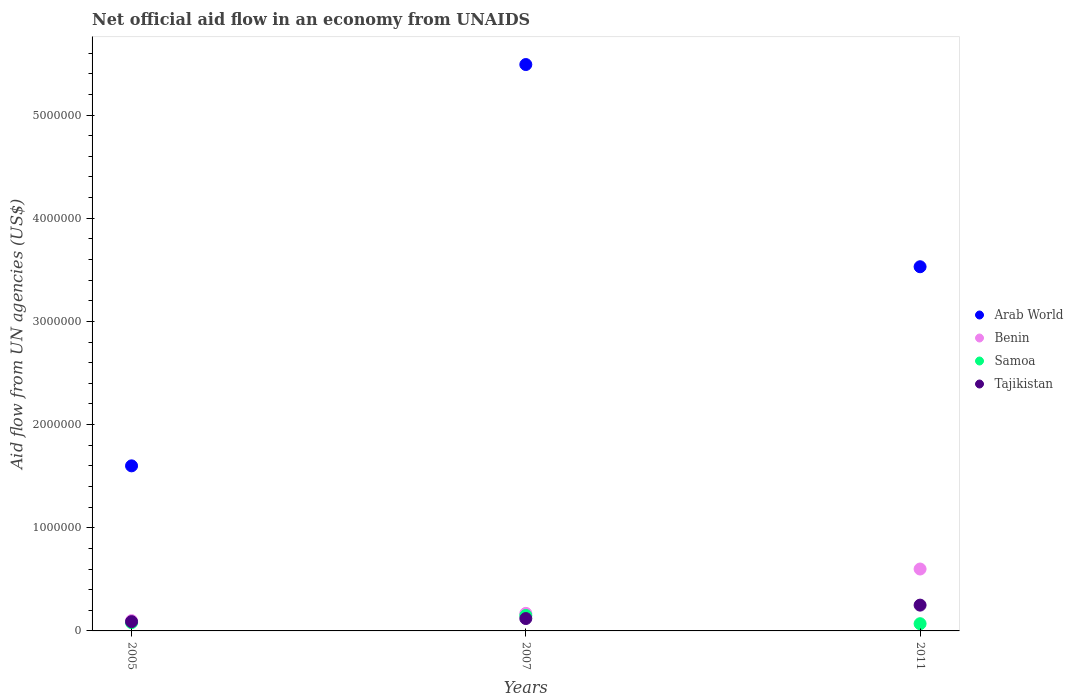What is the net official aid flow in Benin in 2005?
Offer a very short reply. 1.00e+05. Across all years, what is the maximum net official aid flow in Tajikistan?
Give a very brief answer. 2.50e+05. Across all years, what is the minimum net official aid flow in Tajikistan?
Provide a succinct answer. 9.00e+04. What is the total net official aid flow in Tajikistan in the graph?
Your answer should be compact. 4.60e+05. What is the difference between the net official aid flow in Benin in 2005 and that in 2011?
Offer a very short reply. -5.00e+05. What is the difference between the net official aid flow in Tajikistan in 2011 and the net official aid flow in Arab World in 2007?
Make the answer very short. -5.24e+06. What is the average net official aid flow in Arab World per year?
Make the answer very short. 3.54e+06. In how many years, is the net official aid flow in Tajikistan greater than 3000000 US$?
Ensure brevity in your answer.  0. What is the ratio of the net official aid flow in Tajikistan in 2005 to that in 2011?
Offer a terse response. 0.36. What is the difference between the highest and the lowest net official aid flow in Arab World?
Make the answer very short. 3.89e+06. In how many years, is the net official aid flow in Samoa greater than the average net official aid flow in Samoa taken over all years?
Give a very brief answer. 1. Is the sum of the net official aid flow in Tajikistan in 2007 and 2011 greater than the maximum net official aid flow in Benin across all years?
Offer a very short reply. No. Is it the case that in every year, the sum of the net official aid flow in Arab World and net official aid flow in Benin  is greater than the sum of net official aid flow in Tajikistan and net official aid flow in Samoa?
Provide a succinct answer. Yes. How many dotlines are there?
Keep it short and to the point. 4. How many years are there in the graph?
Give a very brief answer. 3. Does the graph contain grids?
Provide a succinct answer. No. How are the legend labels stacked?
Ensure brevity in your answer.  Vertical. What is the title of the graph?
Provide a succinct answer. Net official aid flow in an economy from UNAIDS. What is the label or title of the X-axis?
Your answer should be compact. Years. What is the label or title of the Y-axis?
Provide a succinct answer. Aid flow from UN agencies (US$). What is the Aid flow from UN agencies (US$) of Arab World in 2005?
Give a very brief answer. 1.60e+06. What is the Aid flow from UN agencies (US$) of Samoa in 2005?
Your answer should be very brief. 8.00e+04. What is the Aid flow from UN agencies (US$) in Tajikistan in 2005?
Provide a short and direct response. 9.00e+04. What is the Aid flow from UN agencies (US$) of Arab World in 2007?
Offer a terse response. 5.49e+06. What is the Aid flow from UN agencies (US$) of Benin in 2007?
Provide a short and direct response. 1.70e+05. What is the Aid flow from UN agencies (US$) in Samoa in 2007?
Make the answer very short. 1.50e+05. What is the Aid flow from UN agencies (US$) of Tajikistan in 2007?
Your answer should be compact. 1.20e+05. What is the Aid flow from UN agencies (US$) of Arab World in 2011?
Your response must be concise. 3.53e+06. What is the Aid flow from UN agencies (US$) of Benin in 2011?
Provide a succinct answer. 6.00e+05. Across all years, what is the maximum Aid flow from UN agencies (US$) in Arab World?
Your response must be concise. 5.49e+06. Across all years, what is the minimum Aid flow from UN agencies (US$) of Arab World?
Keep it short and to the point. 1.60e+06. Across all years, what is the minimum Aid flow from UN agencies (US$) in Tajikistan?
Your answer should be compact. 9.00e+04. What is the total Aid flow from UN agencies (US$) of Arab World in the graph?
Your answer should be very brief. 1.06e+07. What is the total Aid flow from UN agencies (US$) in Benin in the graph?
Give a very brief answer. 8.70e+05. What is the difference between the Aid flow from UN agencies (US$) in Arab World in 2005 and that in 2007?
Provide a short and direct response. -3.89e+06. What is the difference between the Aid flow from UN agencies (US$) of Benin in 2005 and that in 2007?
Your answer should be very brief. -7.00e+04. What is the difference between the Aid flow from UN agencies (US$) in Samoa in 2005 and that in 2007?
Keep it short and to the point. -7.00e+04. What is the difference between the Aid flow from UN agencies (US$) in Tajikistan in 2005 and that in 2007?
Your answer should be compact. -3.00e+04. What is the difference between the Aid flow from UN agencies (US$) in Arab World in 2005 and that in 2011?
Your answer should be very brief. -1.93e+06. What is the difference between the Aid flow from UN agencies (US$) in Benin in 2005 and that in 2011?
Offer a very short reply. -5.00e+05. What is the difference between the Aid flow from UN agencies (US$) in Arab World in 2007 and that in 2011?
Keep it short and to the point. 1.96e+06. What is the difference between the Aid flow from UN agencies (US$) of Benin in 2007 and that in 2011?
Your answer should be compact. -4.30e+05. What is the difference between the Aid flow from UN agencies (US$) of Arab World in 2005 and the Aid flow from UN agencies (US$) of Benin in 2007?
Provide a short and direct response. 1.43e+06. What is the difference between the Aid flow from UN agencies (US$) in Arab World in 2005 and the Aid flow from UN agencies (US$) in Samoa in 2007?
Keep it short and to the point. 1.45e+06. What is the difference between the Aid flow from UN agencies (US$) in Arab World in 2005 and the Aid flow from UN agencies (US$) in Tajikistan in 2007?
Offer a very short reply. 1.48e+06. What is the difference between the Aid flow from UN agencies (US$) of Benin in 2005 and the Aid flow from UN agencies (US$) of Tajikistan in 2007?
Your response must be concise. -2.00e+04. What is the difference between the Aid flow from UN agencies (US$) of Arab World in 2005 and the Aid flow from UN agencies (US$) of Benin in 2011?
Your answer should be very brief. 1.00e+06. What is the difference between the Aid flow from UN agencies (US$) in Arab World in 2005 and the Aid flow from UN agencies (US$) in Samoa in 2011?
Your answer should be compact. 1.53e+06. What is the difference between the Aid flow from UN agencies (US$) of Arab World in 2005 and the Aid flow from UN agencies (US$) of Tajikistan in 2011?
Give a very brief answer. 1.35e+06. What is the difference between the Aid flow from UN agencies (US$) in Samoa in 2005 and the Aid flow from UN agencies (US$) in Tajikistan in 2011?
Ensure brevity in your answer.  -1.70e+05. What is the difference between the Aid flow from UN agencies (US$) in Arab World in 2007 and the Aid flow from UN agencies (US$) in Benin in 2011?
Your answer should be compact. 4.89e+06. What is the difference between the Aid flow from UN agencies (US$) in Arab World in 2007 and the Aid flow from UN agencies (US$) in Samoa in 2011?
Ensure brevity in your answer.  5.42e+06. What is the difference between the Aid flow from UN agencies (US$) in Arab World in 2007 and the Aid flow from UN agencies (US$) in Tajikistan in 2011?
Your answer should be compact. 5.24e+06. What is the difference between the Aid flow from UN agencies (US$) in Benin in 2007 and the Aid flow from UN agencies (US$) in Samoa in 2011?
Give a very brief answer. 1.00e+05. What is the difference between the Aid flow from UN agencies (US$) in Benin in 2007 and the Aid flow from UN agencies (US$) in Tajikistan in 2011?
Provide a succinct answer. -8.00e+04. What is the average Aid flow from UN agencies (US$) in Arab World per year?
Provide a short and direct response. 3.54e+06. What is the average Aid flow from UN agencies (US$) in Samoa per year?
Your answer should be compact. 1.00e+05. What is the average Aid flow from UN agencies (US$) of Tajikistan per year?
Your response must be concise. 1.53e+05. In the year 2005, what is the difference between the Aid flow from UN agencies (US$) in Arab World and Aid flow from UN agencies (US$) in Benin?
Offer a terse response. 1.50e+06. In the year 2005, what is the difference between the Aid flow from UN agencies (US$) in Arab World and Aid flow from UN agencies (US$) in Samoa?
Make the answer very short. 1.52e+06. In the year 2005, what is the difference between the Aid flow from UN agencies (US$) in Arab World and Aid flow from UN agencies (US$) in Tajikistan?
Keep it short and to the point. 1.51e+06. In the year 2005, what is the difference between the Aid flow from UN agencies (US$) in Benin and Aid flow from UN agencies (US$) in Samoa?
Your response must be concise. 2.00e+04. In the year 2005, what is the difference between the Aid flow from UN agencies (US$) in Benin and Aid flow from UN agencies (US$) in Tajikistan?
Make the answer very short. 10000. In the year 2007, what is the difference between the Aid flow from UN agencies (US$) of Arab World and Aid flow from UN agencies (US$) of Benin?
Provide a succinct answer. 5.32e+06. In the year 2007, what is the difference between the Aid flow from UN agencies (US$) in Arab World and Aid flow from UN agencies (US$) in Samoa?
Provide a short and direct response. 5.34e+06. In the year 2007, what is the difference between the Aid flow from UN agencies (US$) in Arab World and Aid flow from UN agencies (US$) in Tajikistan?
Provide a short and direct response. 5.37e+06. In the year 2007, what is the difference between the Aid flow from UN agencies (US$) of Benin and Aid flow from UN agencies (US$) of Samoa?
Your response must be concise. 2.00e+04. In the year 2011, what is the difference between the Aid flow from UN agencies (US$) in Arab World and Aid flow from UN agencies (US$) in Benin?
Provide a succinct answer. 2.93e+06. In the year 2011, what is the difference between the Aid flow from UN agencies (US$) of Arab World and Aid flow from UN agencies (US$) of Samoa?
Keep it short and to the point. 3.46e+06. In the year 2011, what is the difference between the Aid flow from UN agencies (US$) in Arab World and Aid flow from UN agencies (US$) in Tajikistan?
Offer a terse response. 3.28e+06. In the year 2011, what is the difference between the Aid flow from UN agencies (US$) in Benin and Aid flow from UN agencies (US$) in Samoa?
Your response must be concise. 5.30e+05. What is the ratio of the Aid flow from UN agencies (US$) in Arab World in 2005 to that in 2007?
Your answer should be compact. 0.29. What is the ratio of the Aid flow from UN agencies (US$) of Benin in 2005 to that in 2007?
Keep it short and to the point. 0.59. What is the ratio of the Aid flow from UN agencies (US$) of Samoa in 2005 to that in 2007?
Your response must be concise. 0.53. What is the ratio of the Aid flow from UN agencies (US$) in Arab World in 2005 to that in 2011?
Your answer should be compact. 0.45. What is the ratio of the Aid flow from UN agencies (US$) in Benin in 2005 to that in 2011?
Your answer should be very brief. 0.17. What is the ratio of the Aid flow from UN agencies (US$) of Samoa in 2005 to that in 2011?
Keep it short and to the point. 1.14. What is the ratio of the Aid flow from UN agencies (US$) in Tajikistan in 2005 to that in 2011?
Offer a very short reply. 0.36. What is the ratio of the Aid flow from UN agencies (US$) of Arab World in 2007 to that in 2011?
Keep it short and to the point. 1.56. What is the ratio of the Aid flow from UN agencies (US$) in Benin in 2007 to that in 2011?
Your answer should be compact. 0.28. What is the ratio of the Aid flow from UN agencies (US$) in Samoa in 2007 to that in 2011?
Offer a very short reply. 2.14. What is the ratio of the Aid flow from UN agencies (US$) in Tajikistan in 2007 to that in 2011?
Provide a short and direct response. 0.48. What is the difference between the highest and the second highest Aid flow from UN agencies (US$) of Arab World?
Make the answer very short. 1.96e+06. What is the difference between the highest and the second highest Aid flow from UN agencies (US$) in Samoa?
Make the answer very short. 7.00e+04. What is the difference between the highest and the lowest Aid flow from UN agencies (US$) in Arab World?
Give a very brief answer. 3.89e+06. What is the difference between the highest and the lowest Aid flow from UN agencies (US$) in Benin?
Offer a terse response. 5.00e+05. 